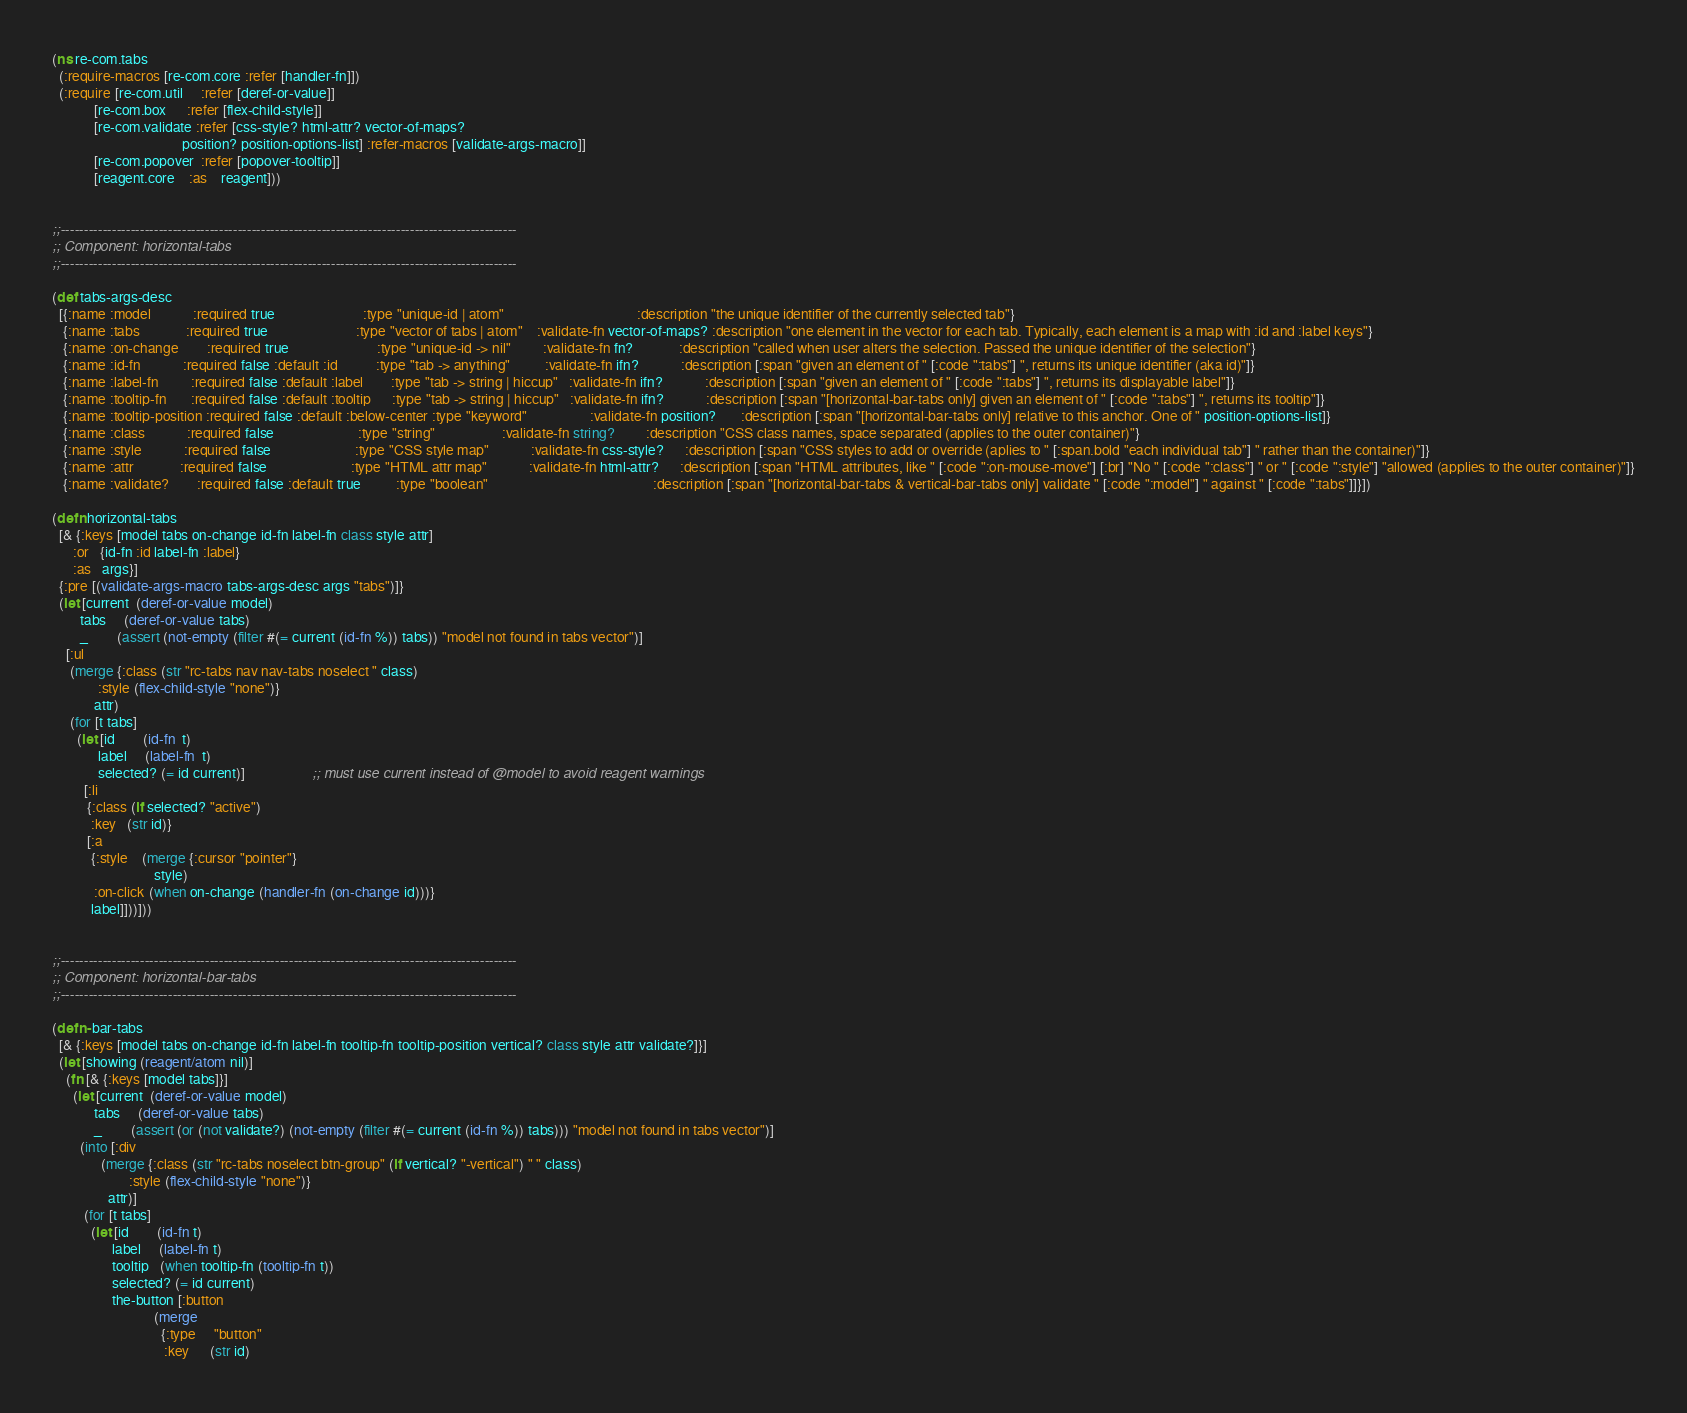<code> <loc_0><loc_0><loc_500><loc_500><_Clojure_>(ns re-com.tabs
  (:require-macros [re-com.core :refer [handler-fn]])
  (:require [re-com.util     :refer [deref-or-value]]
            [re-com.box      :refer [flex-child-style]]
            [re-com.validate :refer [css-style? html-attr? vector-of-maps?
                                     position? position-options-list] :refer-macros [validate-args-macro]]
            [re-com.popover  :refer [popover-tooltip]]
            [reagent.core    :as    reagent]))


;;--------------------------------------------------------------------------------------------------
;; Component: horizontal-tabs
;;--------------------------------------------------------------------------------------------------

(def tabs-args-desc
  [{:name :model            :required true                         :type "unique-id | atom"                                      :description "the unique identifier of the currently selected tab"}
   {:name :tabs             :required true                         :type "vector of tabs | atom"    :validate-fn vector-of-maps? :description "one element in the vector for each tab. Typically, each element is a map with :id and :label keys"}
   {:name :on-change        :required true                         :type "unique-id -> nil"         :validate-fn fn?             :description "called when user alters the selection. Passed the unique identifier of the selection"}
   {:name :id-fn            :required false :default :id           :type "tab -> anything"          :validate-fn ifn?            :description [:span "given an element of " [:code ":tabs"] ", returns its unique identifier (aka id)"]}
   {:name :label-fn         :required false :default :label        :type "tab -> string | hiccup"   :validate-fn ifn?            :description [:span "given an element of " [:code ":tabs"] ", returns its displayable label"]}
   {:name :tooltip-fn       :required false :default :tooltip      :type "tab -> string | hiccup"   :validate-fn ifn?            :description [:span "[horizontal-bar-tabs only] given an element of " [:code ":tabs"] ", returns its tooltip"]}
   {:name :tooltip-position :required false :default :below-center :type "keyword"                  :validate-fn position?       :description [:span "[horizontal-bar-tabs only] relative to this anchor. One of " position-options-list]}
   {:name :class            :required false                        :type "string"                   :validate-fn string?         :description "CSS class names, space separated (applies to the outer container)"}
   {:name :style            :required false                        :type "CSS style map"            :validate-fn css-style?      :description [:span "CSS styles to add or override (aplies to " [:span.bold "each individual tab"] " rather than the container)"]}
   {:name :attr             :required false                        :type "HTML attr map"            :validate-fn html-attr?      :description [:span "HTML attributes, like " [:code ":on-mouse-move"] [:br] "No " [:code ":class"] " or " [:code ":style"] "allowed (applies to the outer container)"]}
   {:name :validate?        :required false :default true          :type "boolean"                                               :description [:span "[horizontal-bar-tabs & vertical-bar-tabs only] validate " [:code ":model"] " against " [:code ":tabs"]]}])

(defn horizontal-tabs
  [& {:keys [model tabs on-change id-fn label-fn class style attr]
      :or   {id-fn :id label-fn :label}
      :as   args}]
  {:pre [(validate-args-macro tabs-args-desc args "tabs")]}
  (let [current  (deref-or-value model)
        tabs     (deref-or-value tabs)
        _        (assert (not-empty (filter #(= current (id-fn %)) tabs)) "model not found in tabs vector")]
    [:ul
     (merge {:class (str "rc-tabs nav nav-tabs noselect " class)
             :style (flex-child-style "none")}
            attr)
     (for [t tabs]
       (let [id        (id-fn  t)
             label     (label-fn  t)
             selected? (= id current)]                   ;; must use current instead of @model to avoid reagent warnings
         [:li
          {:class (if selected? "active")
           :key   (str id)}
          [:a
           {:style    (merge {:cursor "pointer"}
                             style)
            :on-click (when on-change (handler-fn (on-change id)))}
           label]]))]))


;;--------------------------------------------------------------------------------------------------
;; Component: horizontal-bar-tabs
;;--------------------------------------------------------------------------------------------------

(defn- bar-tabs
  [& {:keys [model tabs on-change id-fn label-fn tooltip-fn tooltip-position vertical? class style attr validate?]}]
  (let [showing (reagent/atom nil)]
    (fn [& {:keys [model tabs]}]
      (let [current  (deref-or-value model)
            tabs     (deref-or-value tabs)
            _        (assert (or (not validate?) (not-empty (filter #(= current (id-fn %)) tabs))) "model not found in tabs vector")]
        (into [:div
              (merge {:class (str "rc-tabs noselect btn-group" (if vertical? "-vertical") " " class)
                      :style (flex-child-style "none")}
                attr)]
         (for [t tabs]
           (let [id        (id-fn t)
                 label     (label-fn t)
                 tooltip   (when tooltip-fn (tooltip-fn t))
                 selected? (= id current)
                 the-button [:button
                             (merge
                               {:type     "button"
                                :key      (str id)</code> 